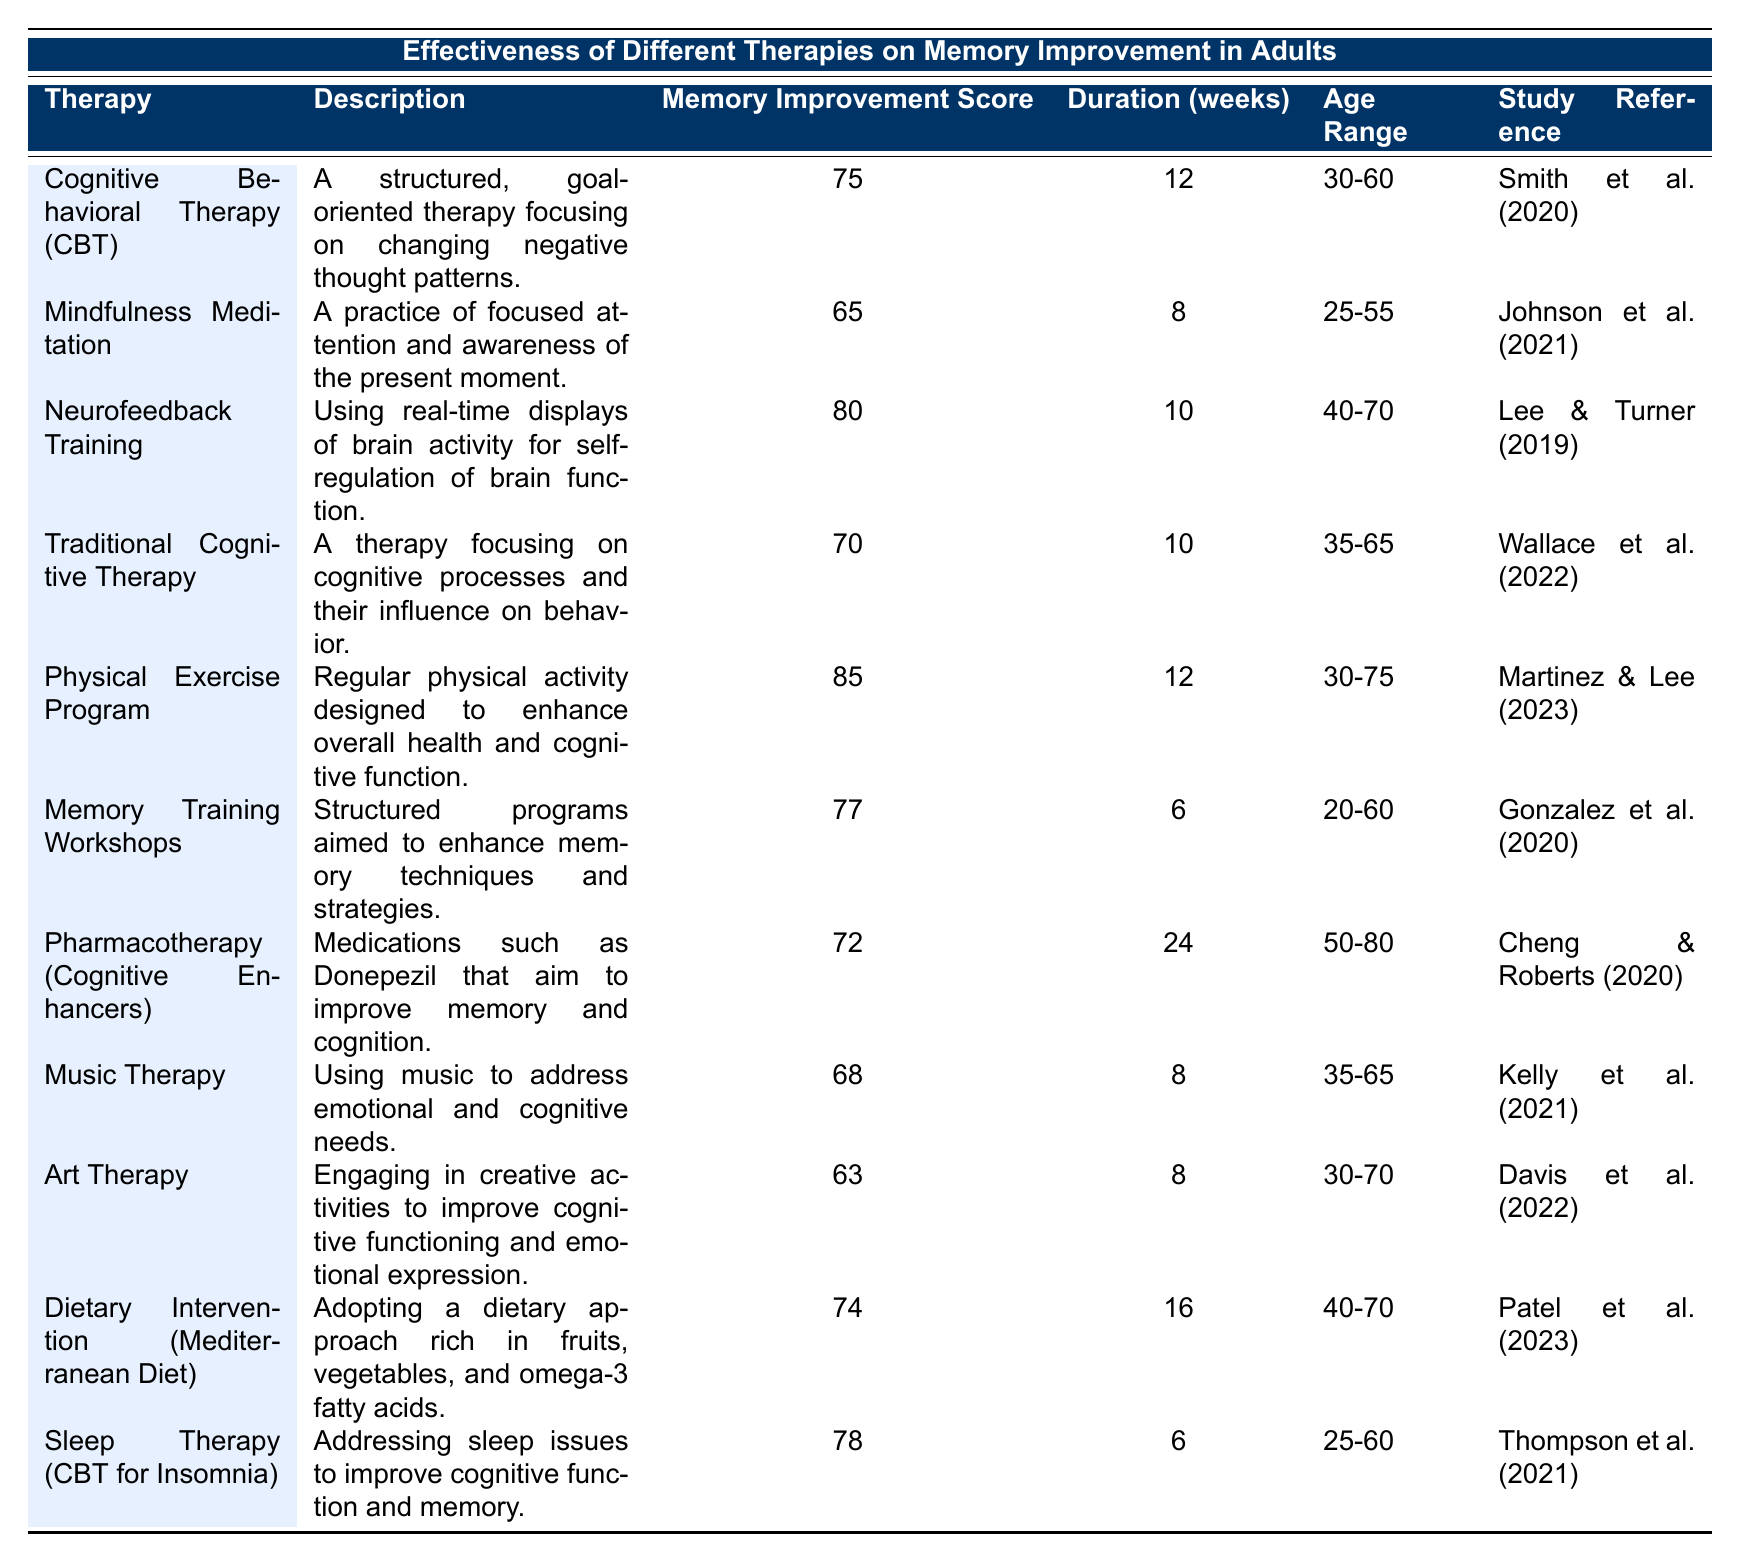What therapy has the highest memory improvement score? The table lists the memory improvement scores for each therapy, with the Physical Exercise Program having the highest score of 85.
Answer: Physical Exercise Program How long does the Cognitive Behavioral Therapy (CBT) last? The duration for Cognitive Behavioral Therapy (CBT) is stated in the table as 12 weeks.
Answer: 12 weeks Is the memory improvement score for Music Therapy higher than 70? The memory improvement score for Music Therapy is 68 as shown in the table, which is less than 70, therefore the statement is false.
Answer: No Which therapy has a duration of 24 weeks and what is its memory improvement score? Looking at the table, Pharmacotherapy (Cognitive Enhancers) has a duration of 24 weeks and a memory improvement score of 72.
Answer: Pharmacotherapy (Cognitive Enhancers), 72 What is the average memory improvement score for therapies with a duration of 8 weeks? The therapies with a duration of 8 weeks are Mindfulness Meditation (65), Music Therapy (68), and Art Therapy (63). Adding these scores gives 65 + 68 + 63 = 196, and there are 3 therapies, so the average is 196 / 3 = 65.33.
Answer: 65.33 Which therapies are suitable for participants aged 30-60? The therapies listed for participants aged 30-60 are Cognitive Behavioral Therapy (CBT), Physical Exercise Program, and Sleep Therapy (CBT for Insomnia).
Answer: CBT, Physical Exercise Program, Sleep Therapy Is the memory improvement score for Dietary Intervention (Mediterranean Diet) greater than that of Traditional Cognitive Therapy? The score for Dietary Intervention (Mediterranean Diet) is 74 and for Traditional Cognitive Therapy it is 70, hence the statement is true.
Answer: Yes What is the difference between the memory improvement scores of Neurofeedback Training and Art Therapy? The memory improvement score for Neurofeedback Training is 80, while for Art Therapy, it is 63. The difference is 80 - 63 = 17.
Answer: 17 What percentage of therapies listed in the table have a memory improvement score of at least 75? There are a total of 11 therapies. The therapies with scores of 75 or more are CBT (75), Neurofeedback Training (80), Physical Exercise Program (85), and Memory Training Workshops (77), resulting in 4 therapies. Therefore, the percentage is (4/11)*100 = 36.36%.
Answer: 36.36% How many therapies involved a physical activity component? Only the Physical Exercise Program explicitly emphasizes a physical activity component, as indicated in its description.
Answer: 1 